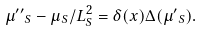<formula> <loc_0><loc_0><loc_500><loc_500>\mu { ^ { \prime \prime } } _ { S } - \mu _ { S } / L ^ { 2 } _ { S } = \delta ( x ) \Delta ( \mu { ^ { \prime } } _ { S } ) .</formula> 